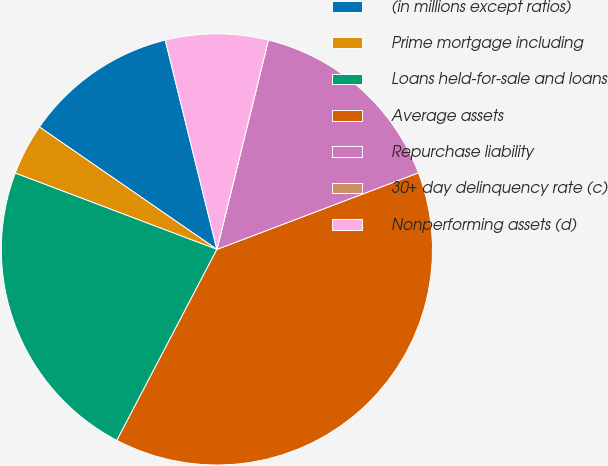Convert chart to OTSL. <chart><loc_0><loc_0><loc_500><loc_500><pie_chart><fcel>(in millions except ratios)<fcel>Prime mortgage including<fcel>Loans held-for-sale and loans<fcel>Average assets<fcel>Repurchase liability<fcel>30+ day delinquency rate (c)<fcel>Nonperforming assets (d)<nl><fcel>11.54%<fcel>3.85%<fcel>23.08%<fcel>38.46%<fcel>15.38%<fcel>0.0%<fcel>7.69%<nl></chart> 